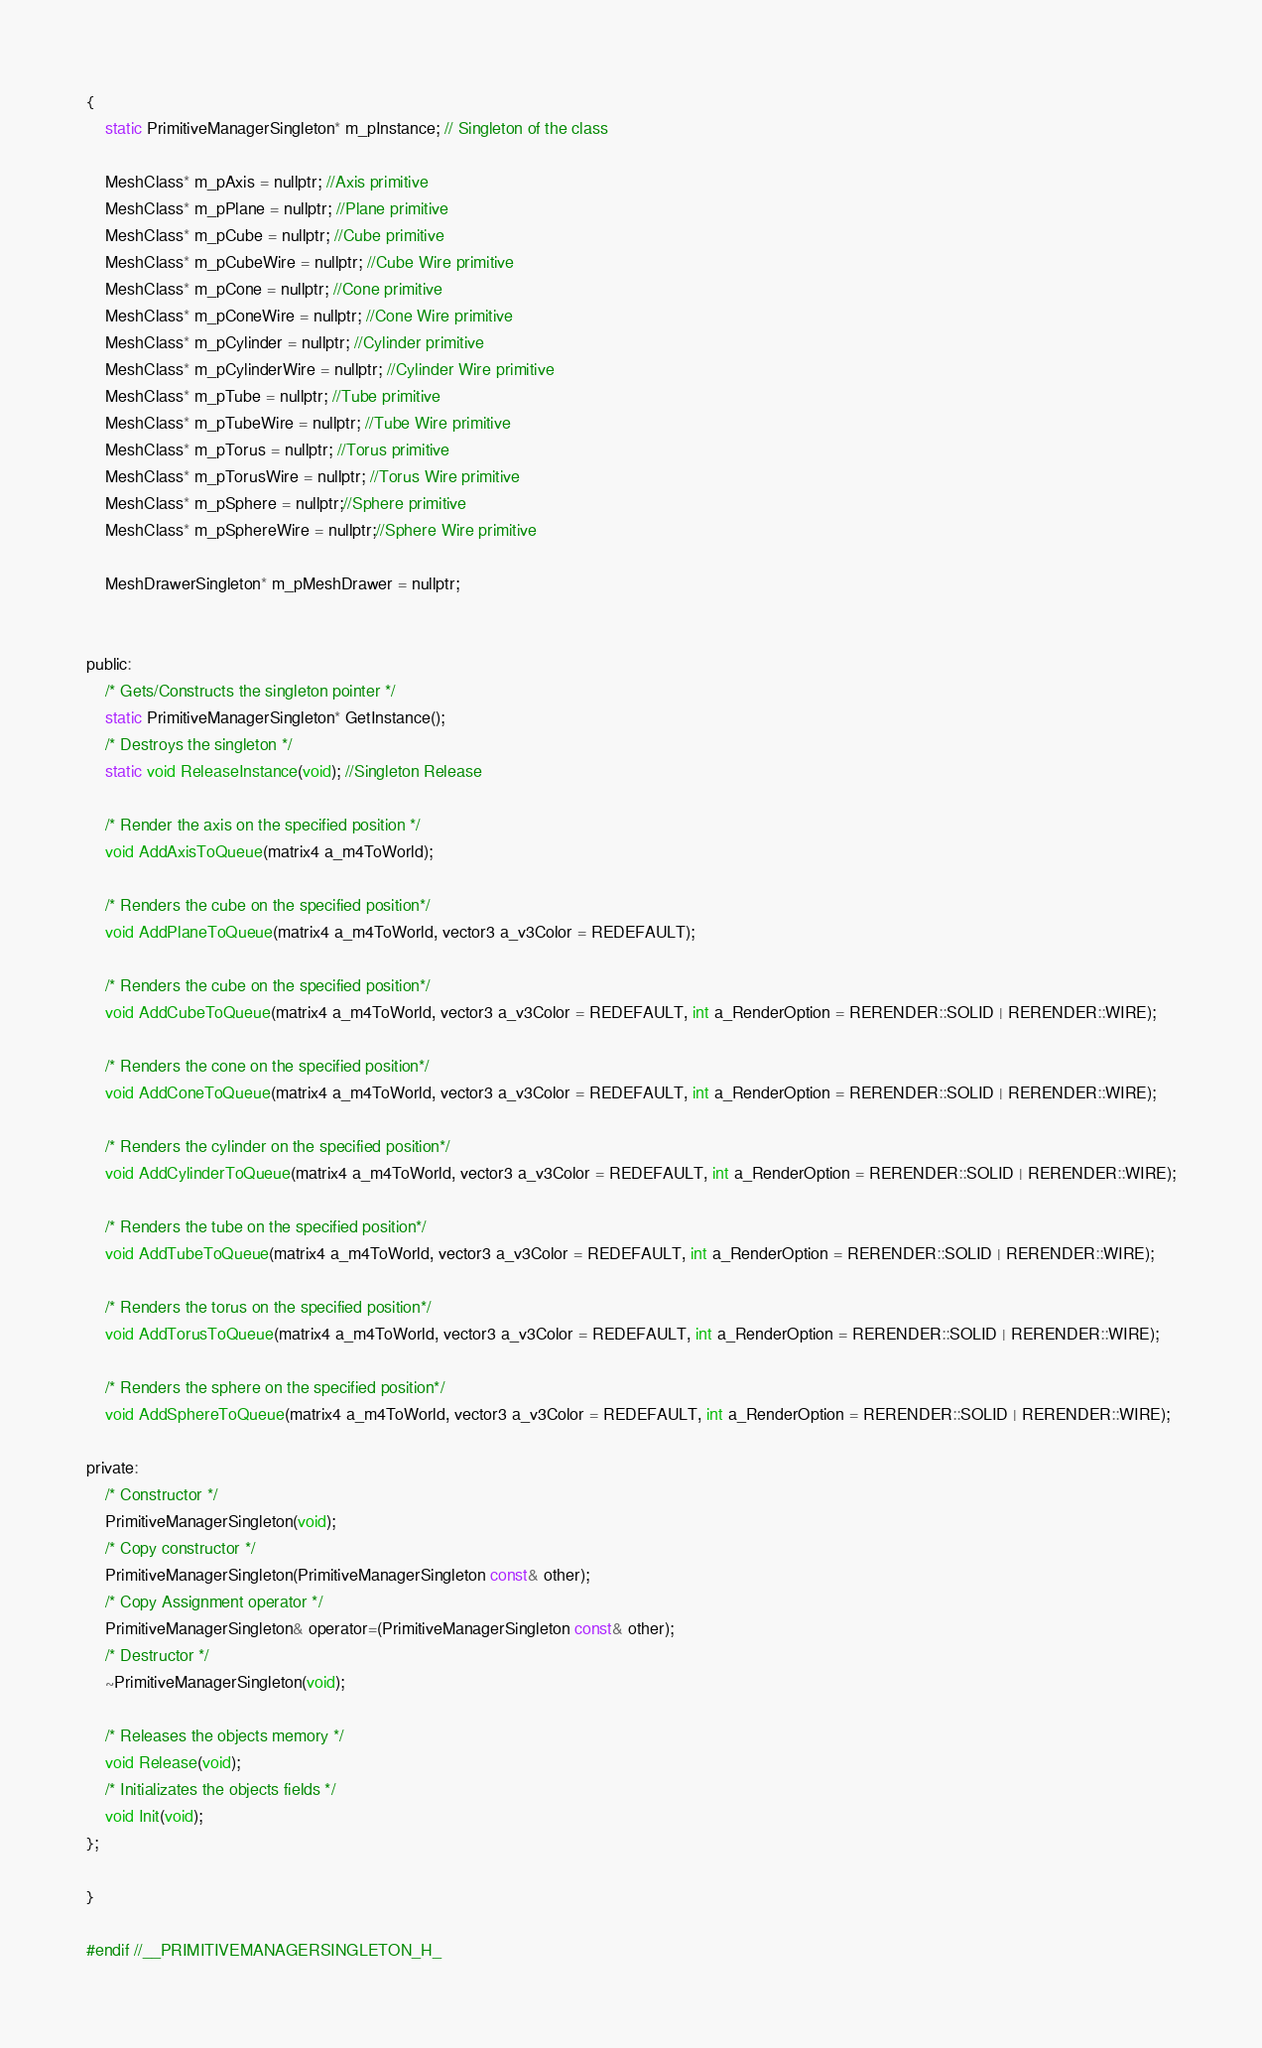Convert code to text. <code><loc_0><loc_0><loc_500><loc_500><_C_>{
	static PrimitiveManagerSingleton* m_pInstance; // Singleton of the class
	
	MeshClass* m_pAxis = nullptr; //Axis primitive
	MeshClass* m_pPlane = nullptr; //Plane primitive
	MeshClass* m_pCube = nullptr; //Cube primitive
	MeshClass* m_pCubeWire = nullptr; //Cube Wire primitive
	MeshClass* m_pCone = nullptr; //Cone primitive
	MeshClass* m_pConeWire = nullptr; //Cone Wire primitive
	MeshClass* m_pCylinder = nullptr; //Cylinder primitive
	MeshClass* m_pCylinderWire = nullptr; //Cylinder Wire primitive
	MeshClass* m_pTube = nullptr; //Tube primitive
	MeshClass* m_pTubeWire = nullptr; //Tube Wire primitive
	MeshClass* m_pTorus = nullptr; //Torus primitive
	MeshClass* m_pTorusWire = nullptr; //Torus Wire primitive
	MeshClass* m_pSphere = nullptr;//Sphere primitive
	MeshClass* m_pSphereWire = nullptr;//Sphere Wire primitive

	MeshDrawerSingleton* m_pMeshDrawer = nullptr;
	

public:
	/* Gets/Constructs the singleton pointer */
	static PrimitiveManagerSingleton* GetInstance();
	/* Destroys the singleton */
	static void ReleaseInstance(void); //Singleton Release

	/* Render the axis on the specified position */
	void AddAxisToQueue(matrix4 a_m4ToWorld);

	/* Renders the cube on the specified position*/
	void AddPlaneToQueue(matrix4 a_m4ToWorld, vector3 a_v3Color = REDEFAULT);

	/* Renders the cube on the specified position*/
	void AddCubeToQueue(matrix4 a_m4ToWorld, vector3 a_v3Color = REDEFAULT, int a_RenderOption = RERENDER::SOLID | RERENDER::WIRE);

	/* Renders the cone on the specified position*/
	void AddConeToQueue(matrix4 a_m4ToWorld, vector3 a_v3Color = REDEFAULT, int a_RenderOption = RERENDER::SOLID | RERENDER::WIRE);

	/* Renders the cylinder on the specified position*/
	void AddCylinderToQueue(matrix4 a_m4ToWorld, vector3 a_v3Color = REDEFAULT, int a_RenderOption = RERENDER::SOLID | RERENDER::WIRE);

	/* Renders the tube on the specified position*/
	void AddTubeToQueue(matrix4 a_m4ToWorld, vector3 a_v3Color = REDEFAULT, int a_RenderOption = RERENDER::SOLID | RERENDER::WIRE);

	/* Renders the torus on the specified position*/
	void AddTorusToQueue(matrix4 a_m4ToWorld, vector3 a_v3Color = REDEFAULT, int a_RenderOption = RERENDER::SOLID | RERENDER::WIRE);
	
	/* Renders the sphere on the specified position*/
	void AddSphereToQueue(matrix4 a_m4ToWorld, vector3 a_v3Color = REDEFAULT, int a_RenderOption = RERENDER::SOLID | RERENDER::WIRE);
	
private:
	/* Constructor */
	PrimitiveManagerSingleton(void);
	/* Copy constructor */
	PrimitiveManagerSingleton(PrimitiveManagerSingleton const& other);
	/* Copy Assignment operator */
	PrimitiveManagerSingleton& operator=(PrimitiveManagerSingleton const& other);
	/* Destructor */
	~PrimitiveManagerSingleton(void);

	/* Releases the objects memory */
	void Release(void);
	/* Initializates the objects fields */
	void Init(void);
};

}

#endif //__PRIMITIVEMANAGERSINGLETON_H_</code> 